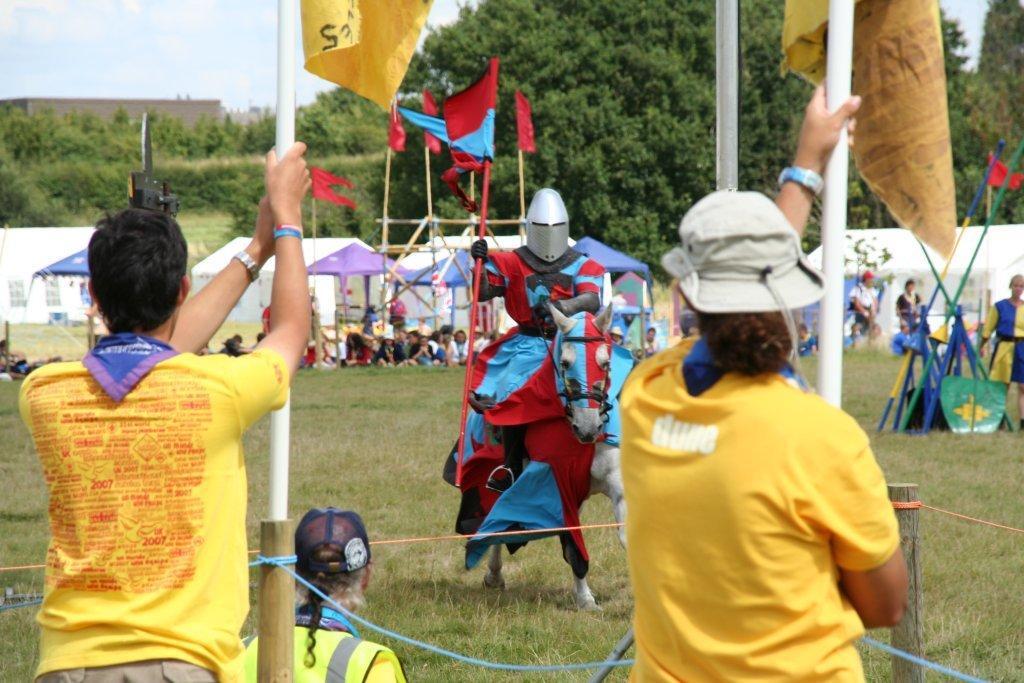Please provide a concise description of this image. In the picture I can see two persons wearing yellow T-shirts are standing and holding an object in their hands and there is a person sitting on a horse which is on a greenery ground in front of them and there are few other persons,some other objects and trees in the background. 